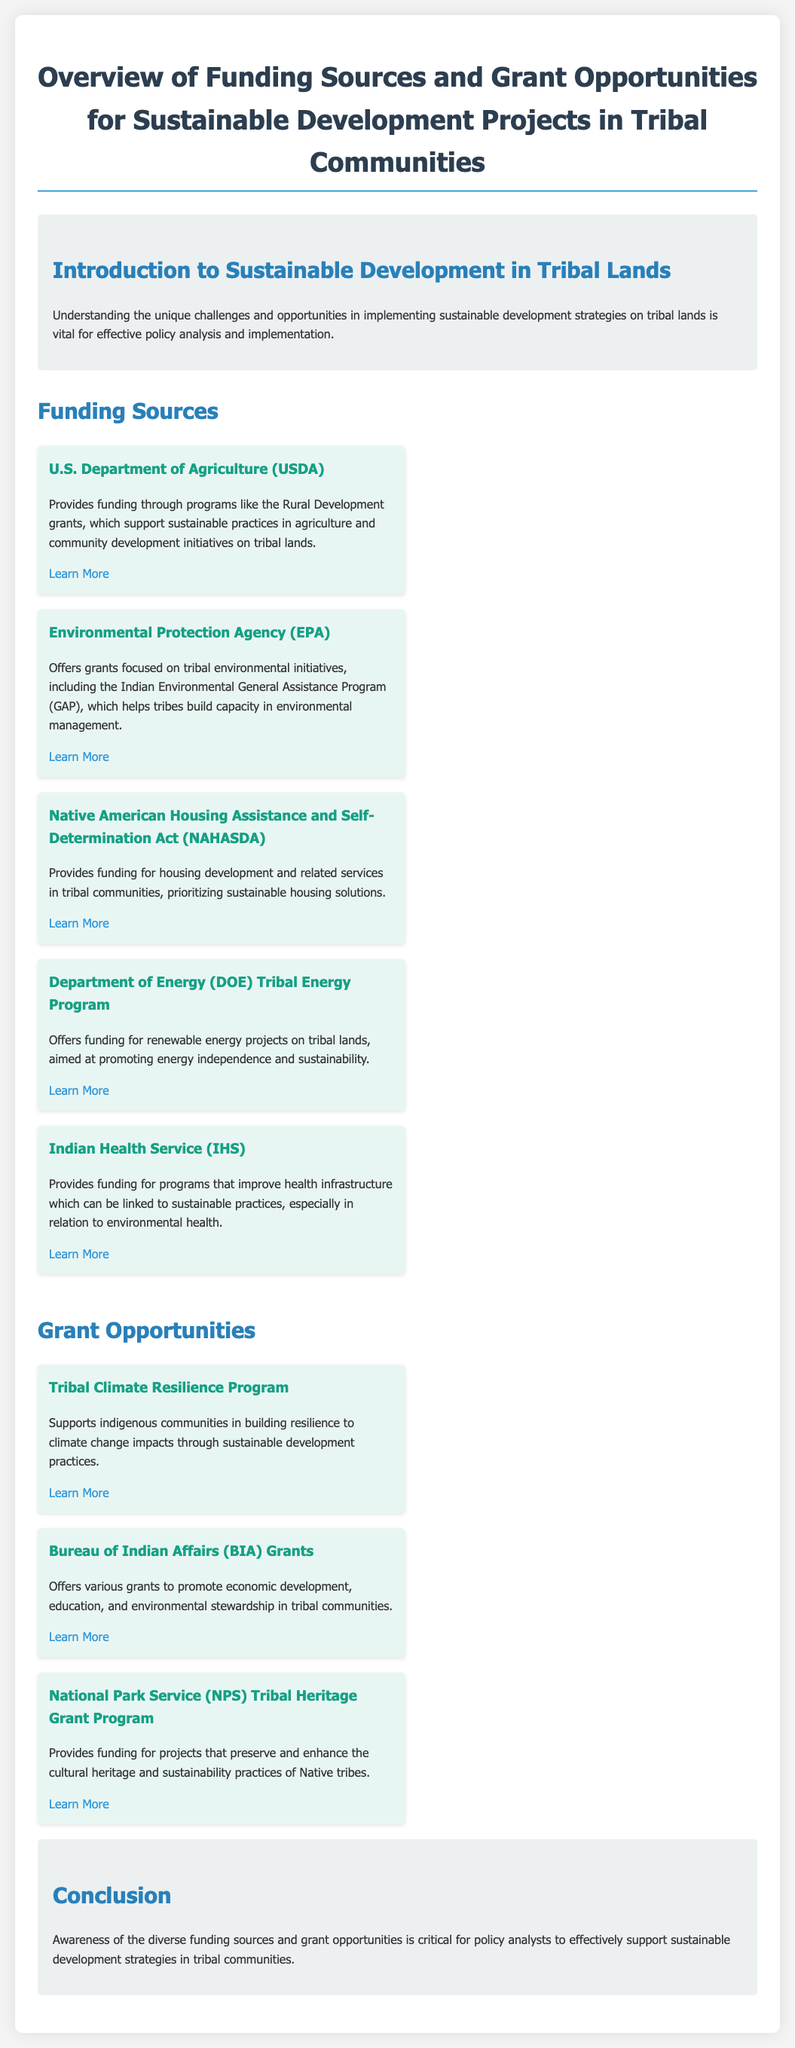What is the primary focus of the funding from the U.S. Department of Agriculture? The U.S. Department of Agriculture provides funding through programs like the Rural Development grants, which support sustainable practices in agriculture and community development initiatives on tribal lands.
Answer: sustainable practices in agriculture What program provides grants for environmental initiatives? The Environmental Protection Agency offers grants focused on tribal environmental initiatives, including the Indian Environmental General Assistance Program, which helps tribes build capacity in environmental management.
Answer: Indian Environmental General Assistance Program Which act prioritizes funding for housing development in tribal communities? The Native American Housing Assistance and Self-Determination Act provides funding for housing development and related services in tribal communities, prioritizing sustainable housing solutions.
Answer: Native American Housing Assistance and Self-Determination Act What is the aim of the Department of Energy Tribal Energy Program? The Department of Energy Tribal Energy Program offers funding for renewable energy projects on tribal lands, aimed at promoting energy independence and sustainability.
Answer: renewable energy projects Which grant supports indigenous communities in climate resilience? The Tribal Climate Resilience Program supports indigenous communities in building resilience to climate change impacts through sustainable development practices.
Answer: Tribal Climate Resilience Program How many sources of funding are listed in the document? The document lists five sources of funding for sustainable development projects in tribal communities.
Answer: five What is the goal of the Bureau of Indian Affairs grants? The Bureau of Indian Affairs offers various grants to promote economic development, education, and environmental stewardship in tribal communities.
Answer: economic development Which funding source is specifically for health infrastructure improvement? The Indian Health Service provides funding for programs that improve health infrastructure which can be linked to sustainable practices.
Answer: Indian Health Service What type of grant does the National Park Service provide? The National Park Service provides funding for projects that preserve and enhance the cultural heritage and sustainability practices of Native tribes.
Answer: cultural heritage and sustainability practices 